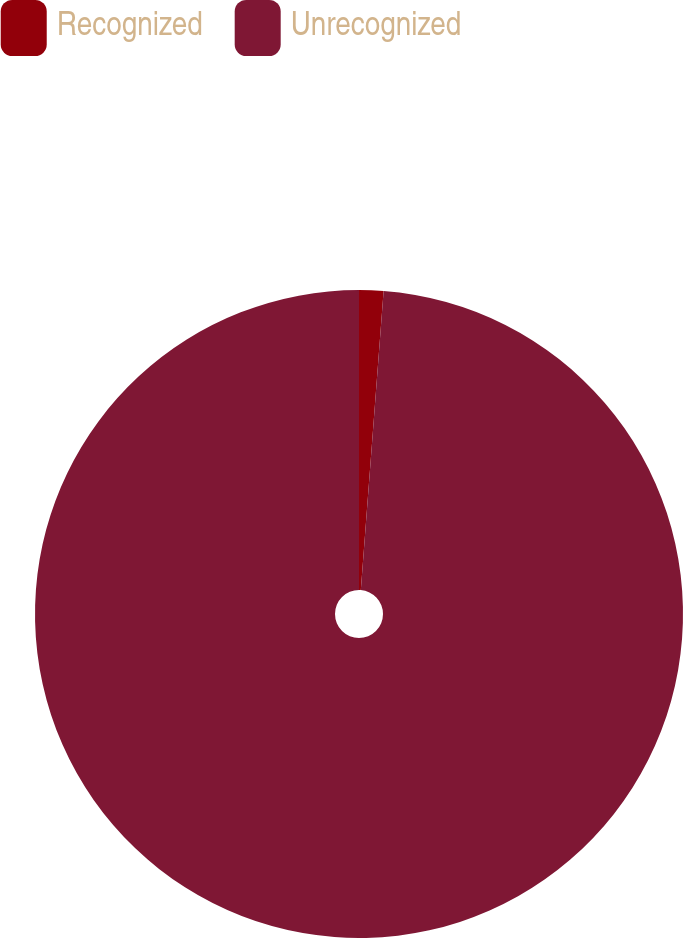<chart> <loc_0><loc_0><loc_500><loc_500><pie_chart><fcel>Recognized<fcel>Unrecognized<nl><fcel>1.21%<fcel>98.79%<nl></chart> 